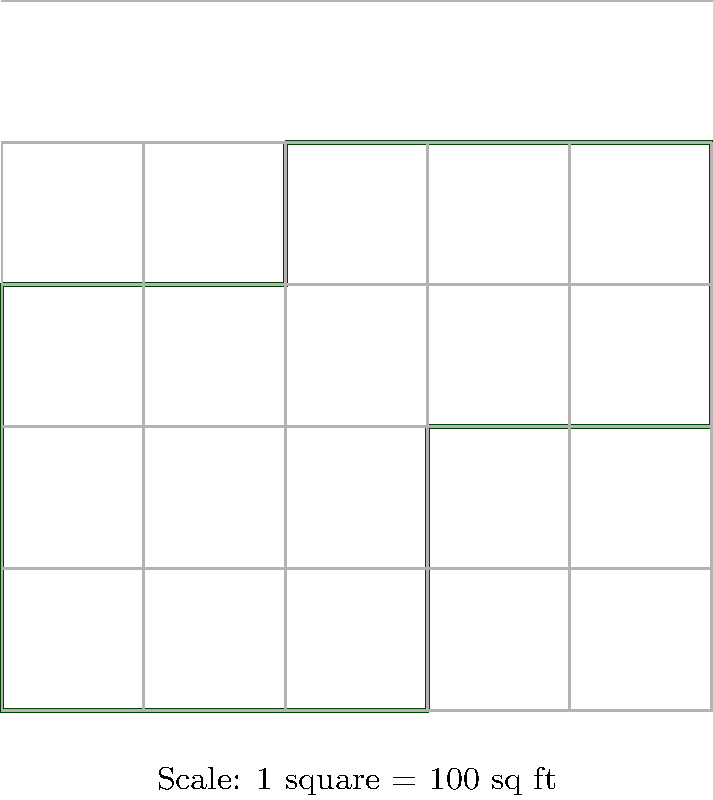As a mortgage brokerage owner, you're evaluating a property with an irregularly shaped lot. Using the provided scaled map with a grid overlay, calculate the total area of the property in square feet. Each grid square represents 100 square feet. To calculate the area of this irregularly shaped property lot, we'll break it down into rectangles and count the squares:

1. Divide the shape into three rectangles:
   a. Bottom rectangle: 3 x 3 = 9 squares
   b. Middle rectangle: 2 x 1 = 2 squares
   c. Top rectangle: 3 x 1 = 3 squares

2. Sum up the total squares:
   $9 + 2 + 3 = 14$ squares

3. Convert to square feet:
   Each square represents 100 sq ft
   $14 \times 100 = 1400$ sq ft

Therefore, the total area of the property lot is 1400 square feet.
Answer: 1400 sq ft 